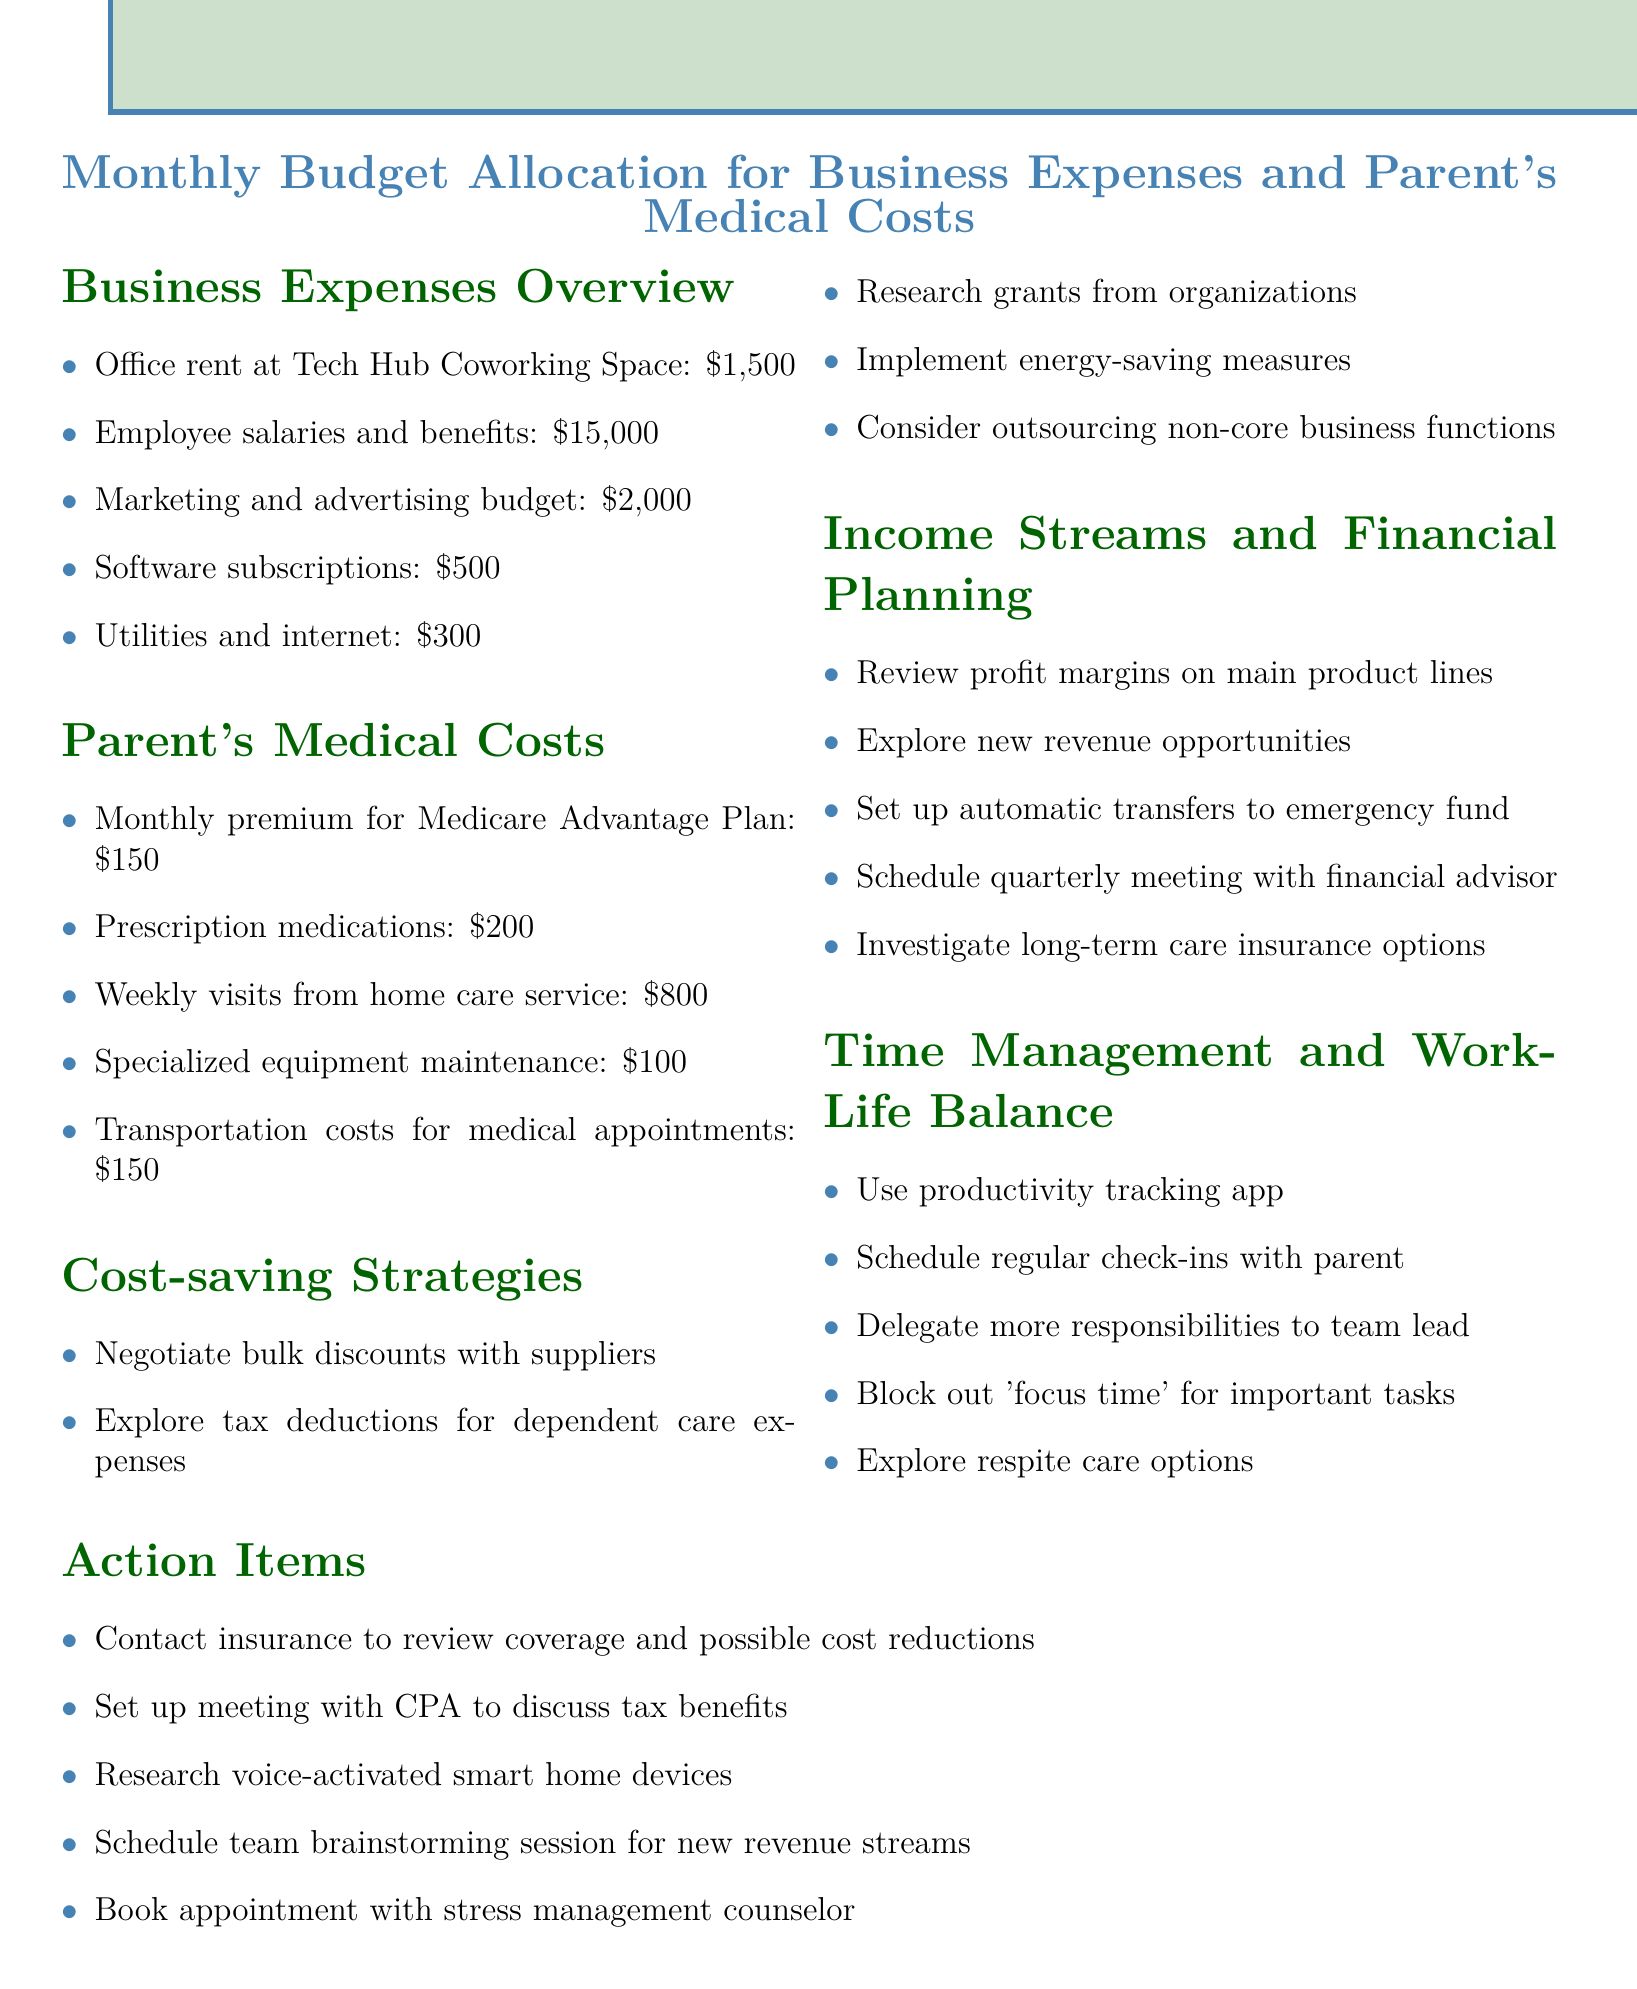What is the total office rent? The total office rent is explicitly mentioned as $1,500 in the document.
Answer: $1,500 How much does the prescription medication cost? The prescription medication cost from CVS Pharmacy is stated as $200 in the document.
Answer: $200 What is the cost for weekly Visits from home care service? The document specifies that weekly visits from the Visiting Angels home care service cost $800.
Answer: $800 What action item involves the CPA? The action item regarding the CPA discusses potential tax benefits for dependent care, indicating a relevant meeting setup.
Answer: Set up meeting with CPA to discuss tax benefits How much is the marketing and advertising budget? The document lists the marketing and advertising budget as $2,000 under business expenses.
Answer: $2,000 How many items are listed under Cost-saving Strategies? The number of items listed under Cost-saving Strategies can be derived from the document, which mentions five strategies.
Answer: Five What is the projected income stream discussed? The document mentions exploring new revenue opportunities as part of financial planning.
Answer: Explore new revenue opportunities What is mentioned as a tool for productivity tracking? The document mentions the use of RescueTime app as a tool for tracking productivity.
Answer: RescueTime app What specialized equipment maintenance is listed? The specialized equipment maintenance for the JAWS screen reader and refreshable Braille display is specified in the document at $100.
Answer: $100 